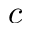Convert formula to latex. <formula><loc_0><loc_0><loc_500><loc_500>c</formula> 